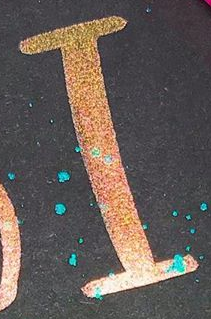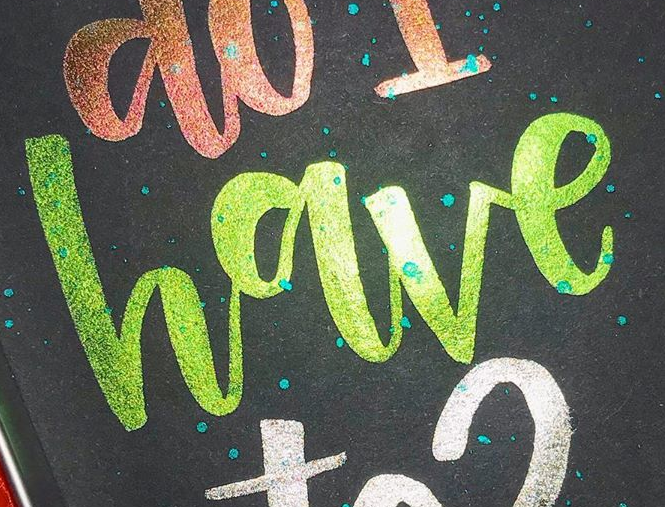What text is displayed in these images sequentially, separated by a semicolon? I; have 